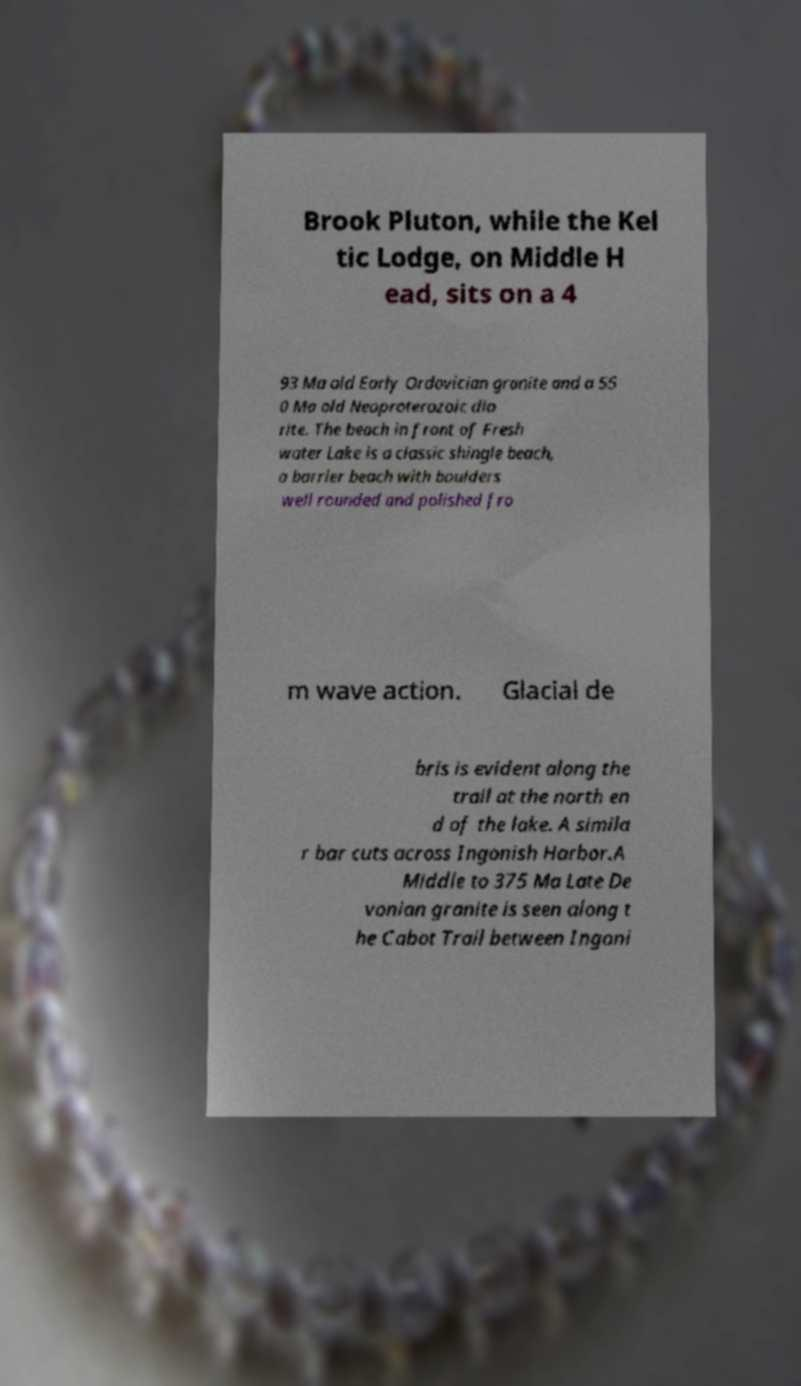Could you extract and type out the text from this image? Brook Pluton, while the Kel tic Lodge, on Middle H ead, sits on a 4 93 Ma old Early Ordovician granite and a 55 0 Ma old Neoproterozoic dio rite. The beach in front of Fresh water Lake is a classic shingle beach, a barrier beach with boulders well rounded and polished fro m wave action. Glacial de bris is evident along the trail at the north en d of the lake. A simila r bar cuts across Ingonish Harbor.A Middle to 375 Ma Late De vonian granite is seen along t he Cabot Trail between Ingoni 